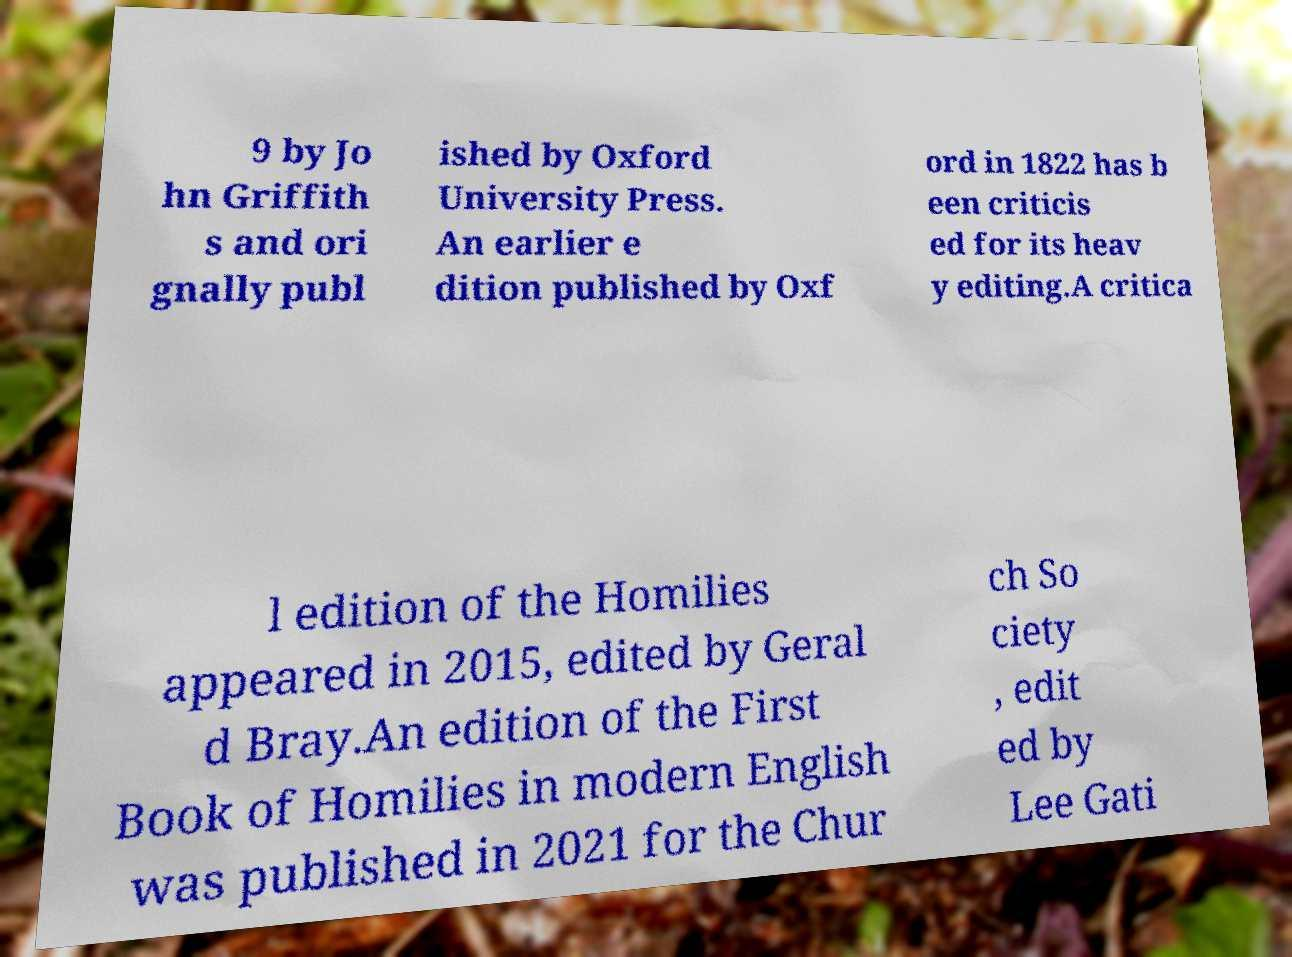There's text embedded in this image that I need extracted. Can you transcribe it verbatim? 9 by Jo hn Griffith s and ori gnally publ ished by Oxford University Press. An earlier e dition published by Oxf ord in 1822 has b een criticis ed for its heav y editing.A critica l edition of the Homilies appeared in 2015, edited by Geral d Bray.An edition of the First Book of Homilies in modern English was published in 2021 for the Chur ch So ciety , edit ed by Lee Gati 